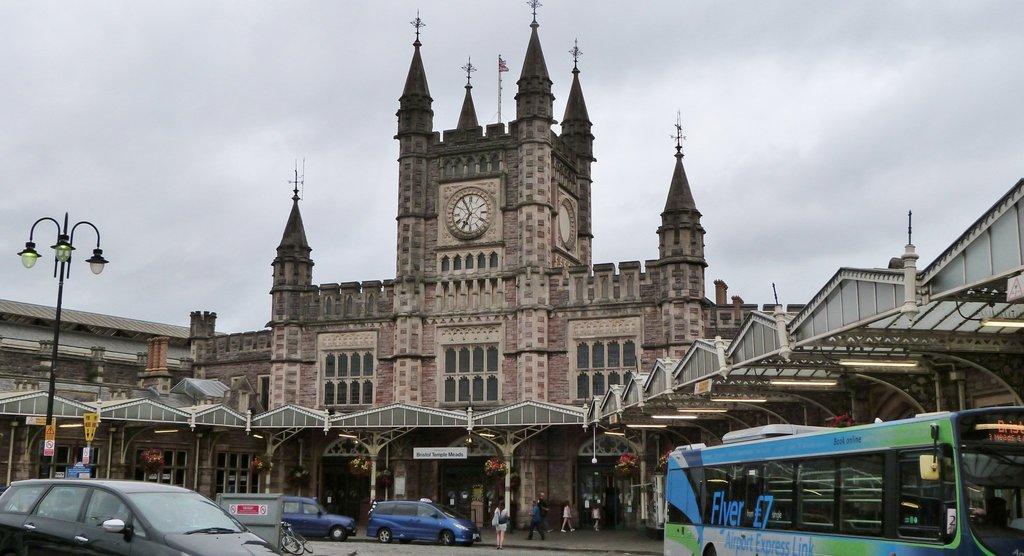Could you give a brief overview of what you see in this image? In this picture there is a brown color church with clock. In the front we can see some iron shed. In the front bottom side there are some blue color cars and buses are parked on the road. On the left side there is a black color lamppost. 